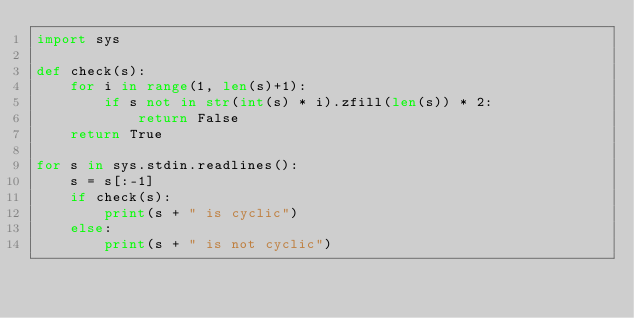<code> <loc_0><loc_0><loc_500><loc_500><_Python_>import sys

def check(s):
    for i in range(1, len(s)+1):
        if s not in str(int(s) * i).zfill(len(s)) * 2:
            return False
    return True

for s in sys.stdin.readlines():
    s = s[:-1]
    if check(s):
        print(s + " is cyclic")
    else:
        print(s + " is not cyclic")
</code> 